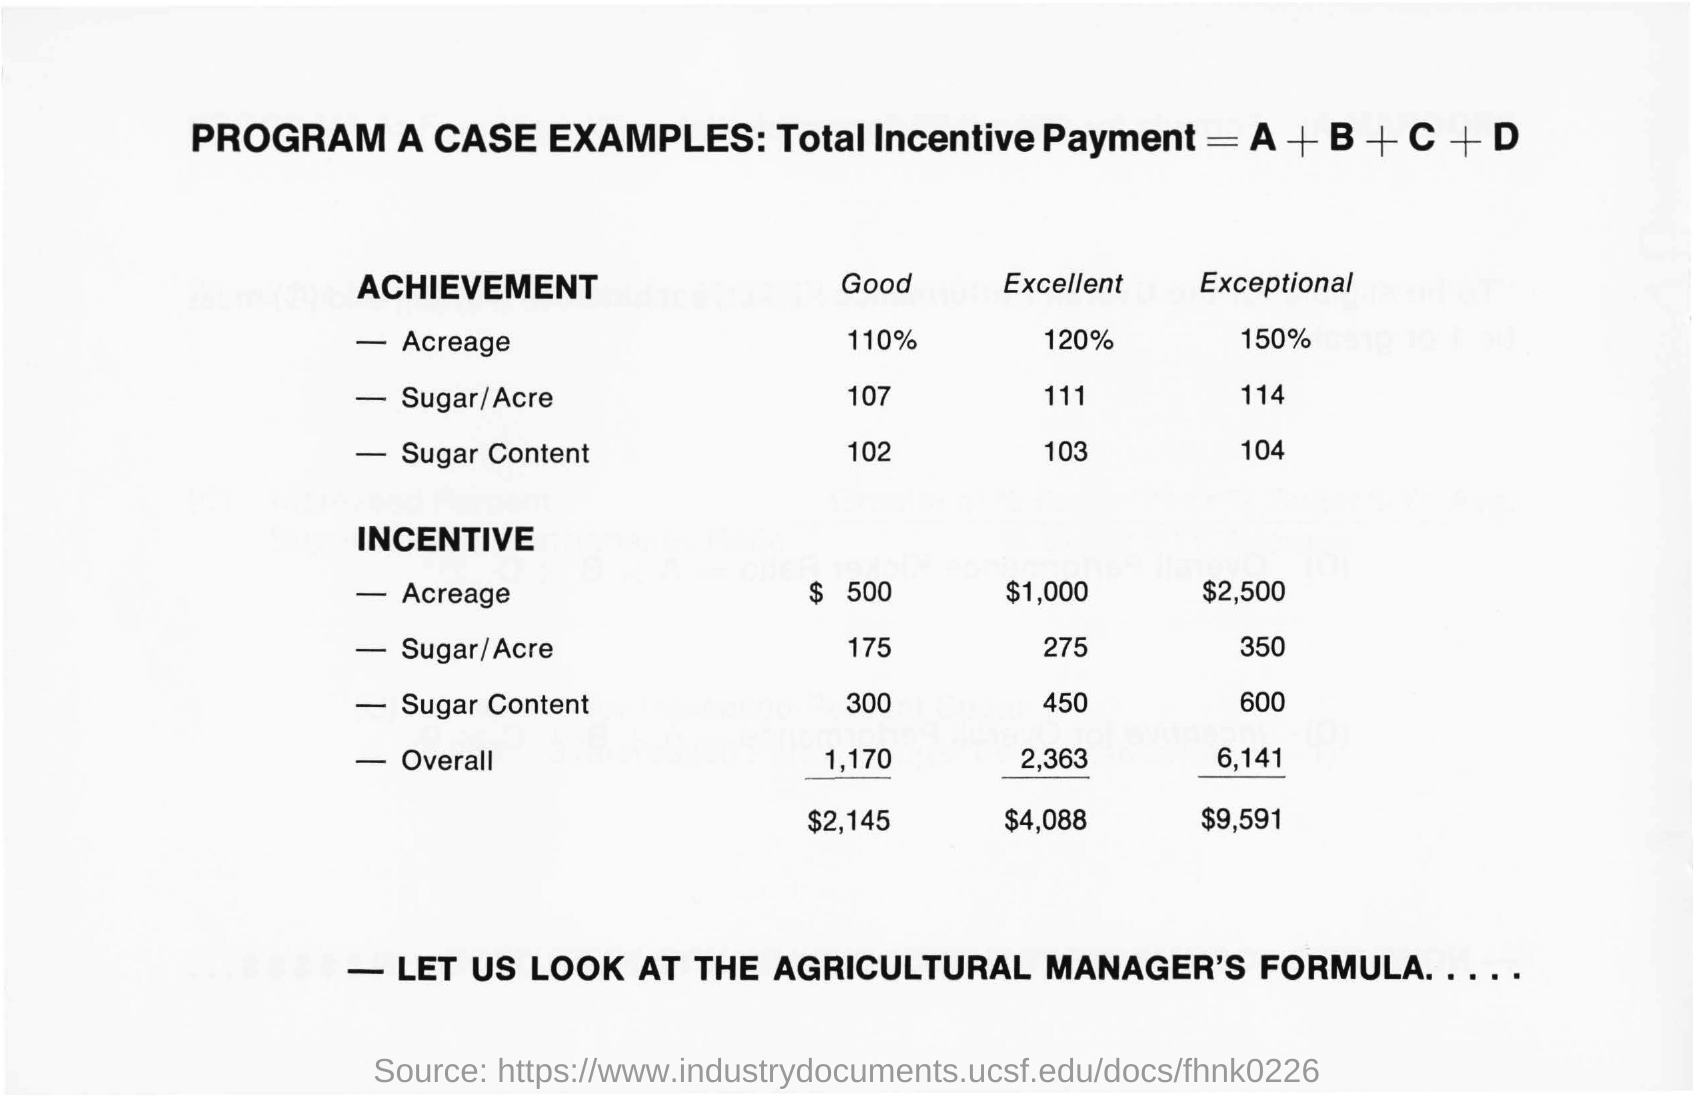Indicate a few pertinent items in this graphic. I am proud to announce that I have received a Sugar/Acre of Excellence award for my exceptional performance, with a score of 111.. Acreage's exceptional performance was 150% of their target. The program is a case example where the total incentive payment is calculated by adding together A, B, C, and D. The achievement of Acreage in Good is 110%. I am not sure what you are trying to ask. Could you please provide more context or clarify your question? 